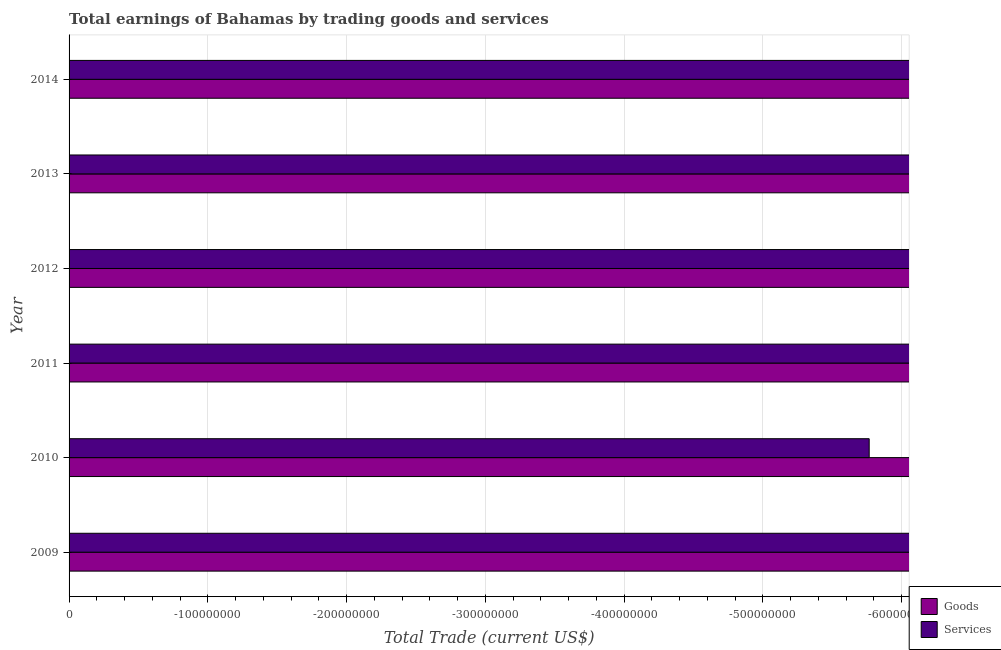How many bars are there on the 2nd tick from the bottom?
Your response must be concise. 0. What is the label of the 1st group of bars from the top?
Provide a succinct answer. 2014. In how many cases, is the number of bars for a given year not equal to the number of legend labels?
Provide a succinct answer. 6. What is the amount earned by trading goods in 2011?
Provide a succinct answer. 0. What is the average amount earned by trading goods per year?
Offer a very short reply. 0. In how many years, is the amount earned by trading goods greater than -340000000 US$?
Give a very brief answer. 0. How many bars are there?
Keep it short and to the point. 0. Are the values on the major ticks of X-axis written in scientific E-notation?
Offer a very short reply. No. Does the graph contain grids?
Ensure brevity in your answer.  Yes. Where does the legend appear in the graph?
Offer a very short reply. Bottom right. How are the legend labels stacked?
Give a very brief answer. Vertical. What is the title of the graph?
Provide a succinct answer. Total earnings of Bahamas by trading goods and services. Does "Automatic Teller Machines" appear as one of the legend labels in the graph?
Provide a short and direct response. No. What is the label or title of the X-axis?
Your answer should be compact. Total Trade (current US$). What is the label or title of the Y-axis?
Your answer should be compact. Year. What is the Total Trade (current US$) of Services in 2009?
Give a very brief answer. 0. What is the Total Trade (current US$) of Goods in 2010?
Your answer should be compact. 0. What is the Total Trade (current US$) in Services in 2012?
Provide a short and direct response. 0. What is the Total Trade (current US$) of Goods in 2014?
Provide a short and direct response. 0. What is the total Total Trade (current US$) of Goods in the graph?
Make the answer very short. 0. What is the total Total Trade (current US$) of Services in the graph?
Make the answer very short. 0. What is the average Total Trade (current US$) in Services per year?
Keep it short and to the point. 0. 